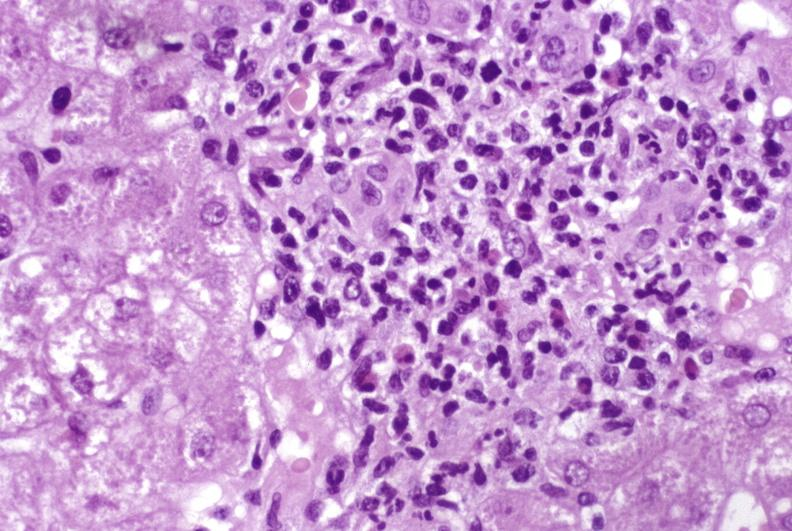does quite good liver show moderate acute rejection?
Answer the question using a single word or phrase. No 